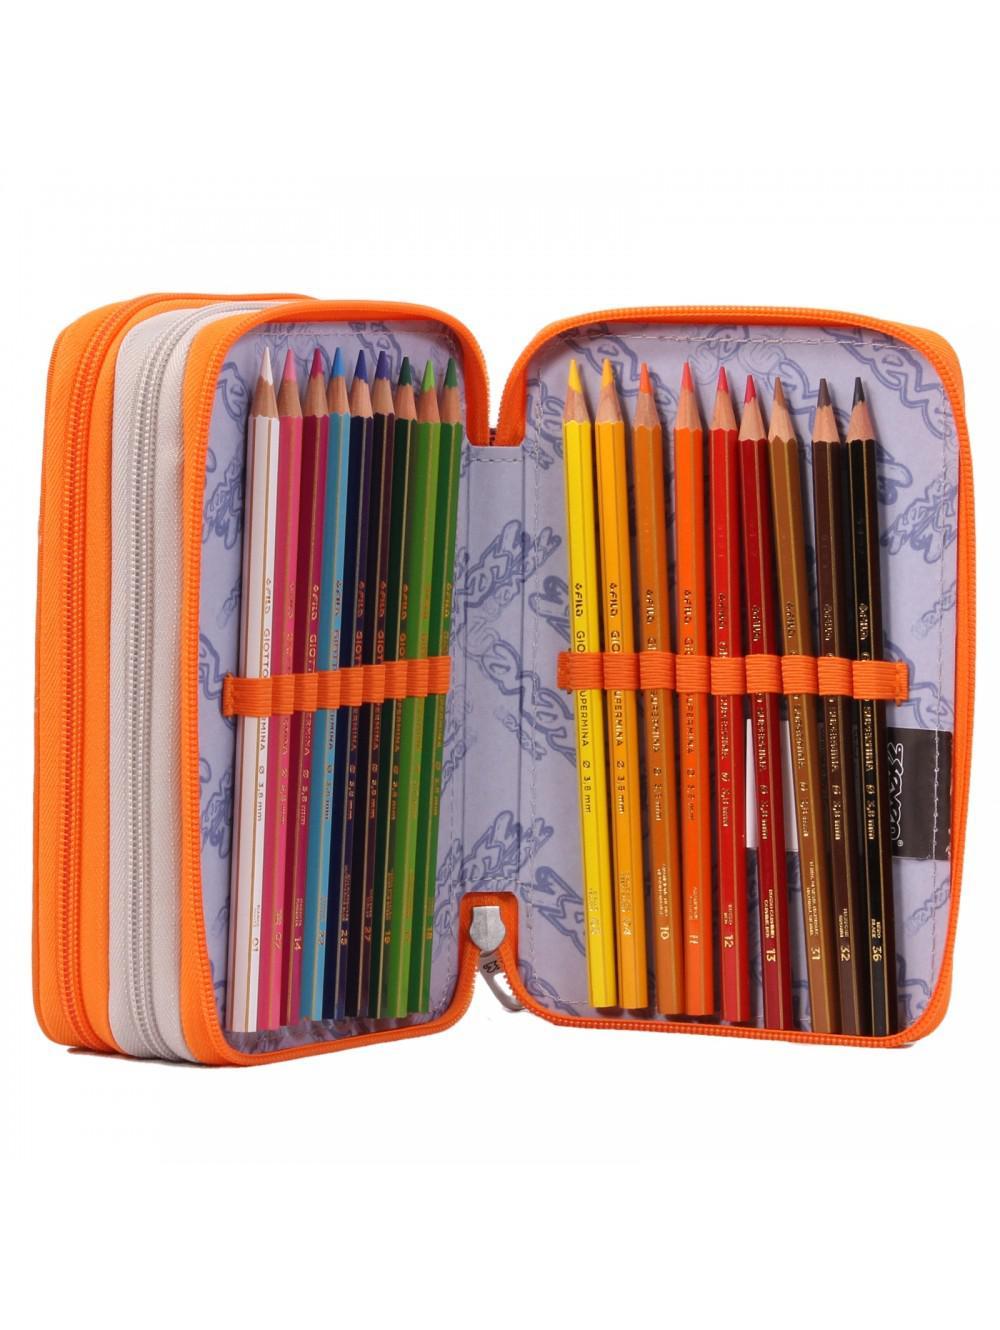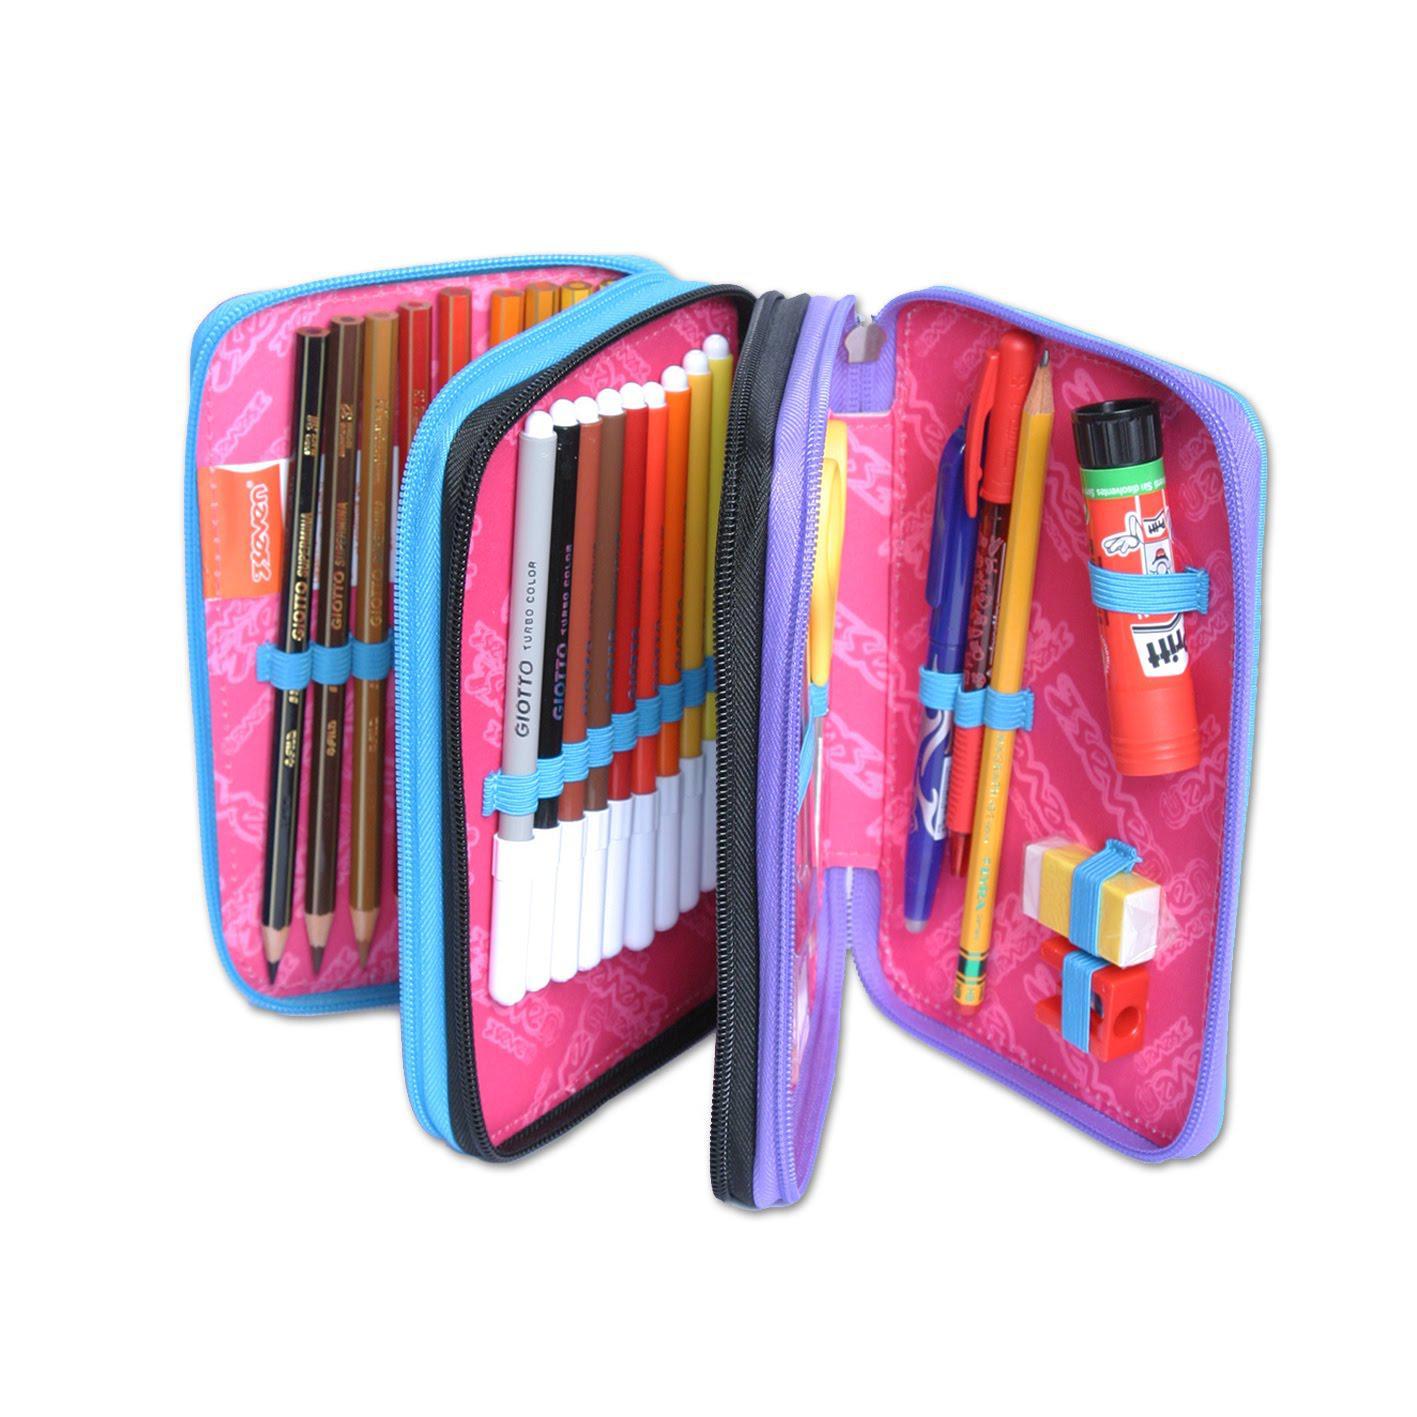The first image is the image on the left, the second image is the image on the right. Given the left and right images, does the statement "One image shows a pencil case with a pink interior displayed so its multiple inner compartments fan out." hold true? Answer yes or no. Yes. The first image is the image on the left, the second image is the image on the right. Assess this claim about the two images: "At least one pencil case has a pink inner lining.". Correct or not? Answer yes or no. Yes. 